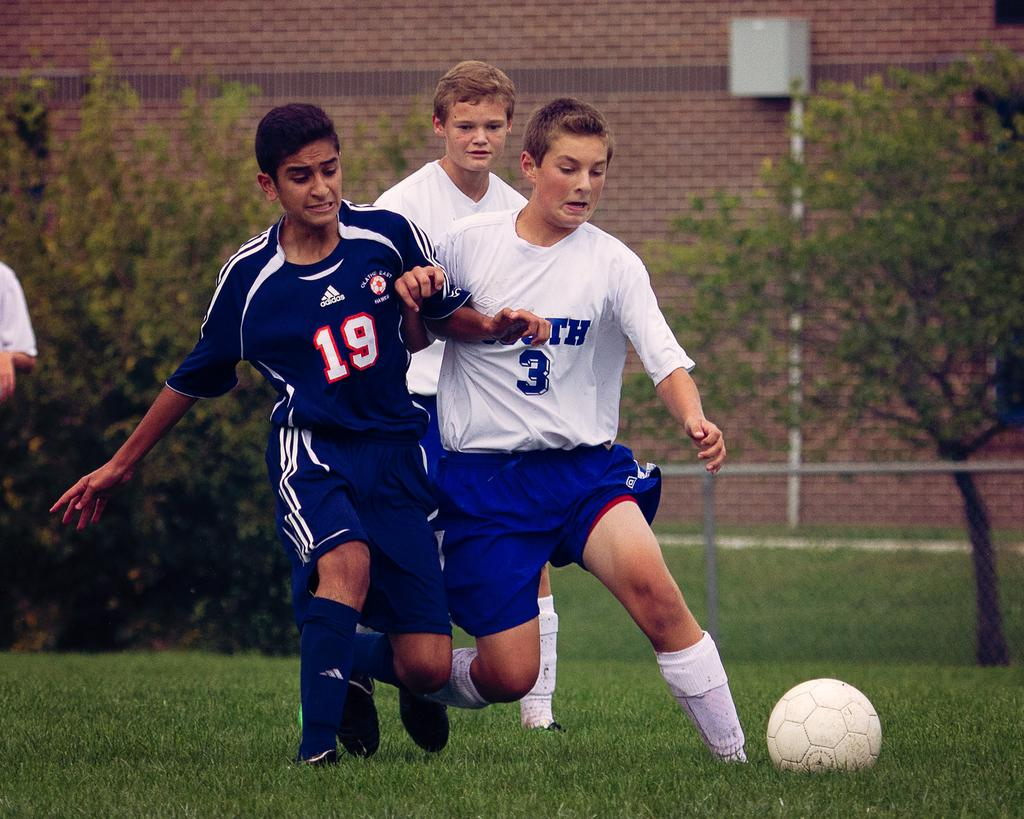<image>
Create a compact narrative representing the image presented. Players 19 and 3 fight for the soccer ball on the playing field. 